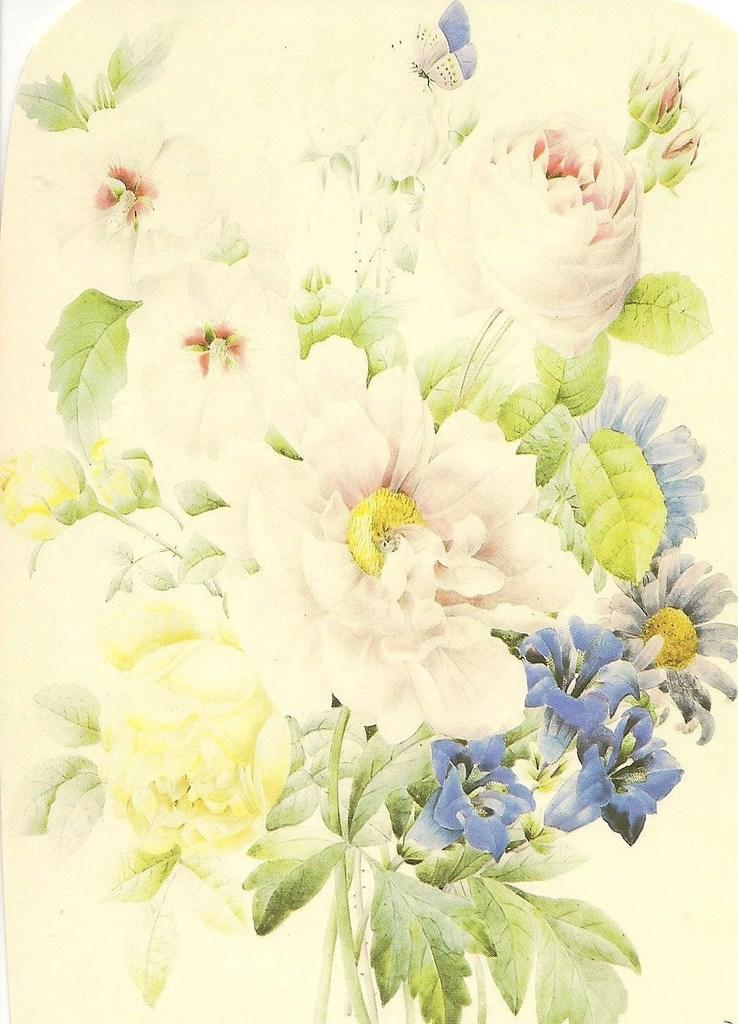What type of artwork is depicted in the image? There are paintings of flowers in the image. How many knots are tied in the paintings of flowers in the image? There are no knots present in the paintings of flowers in the image. What type of cakes are shown in the paintings of flowers in the image? There are no cakes depicted in the paintings of flowers in the image. 